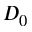<formula> <loc_0><loc_0><loc_500><loc_500>D _ { 0 }</formula> 